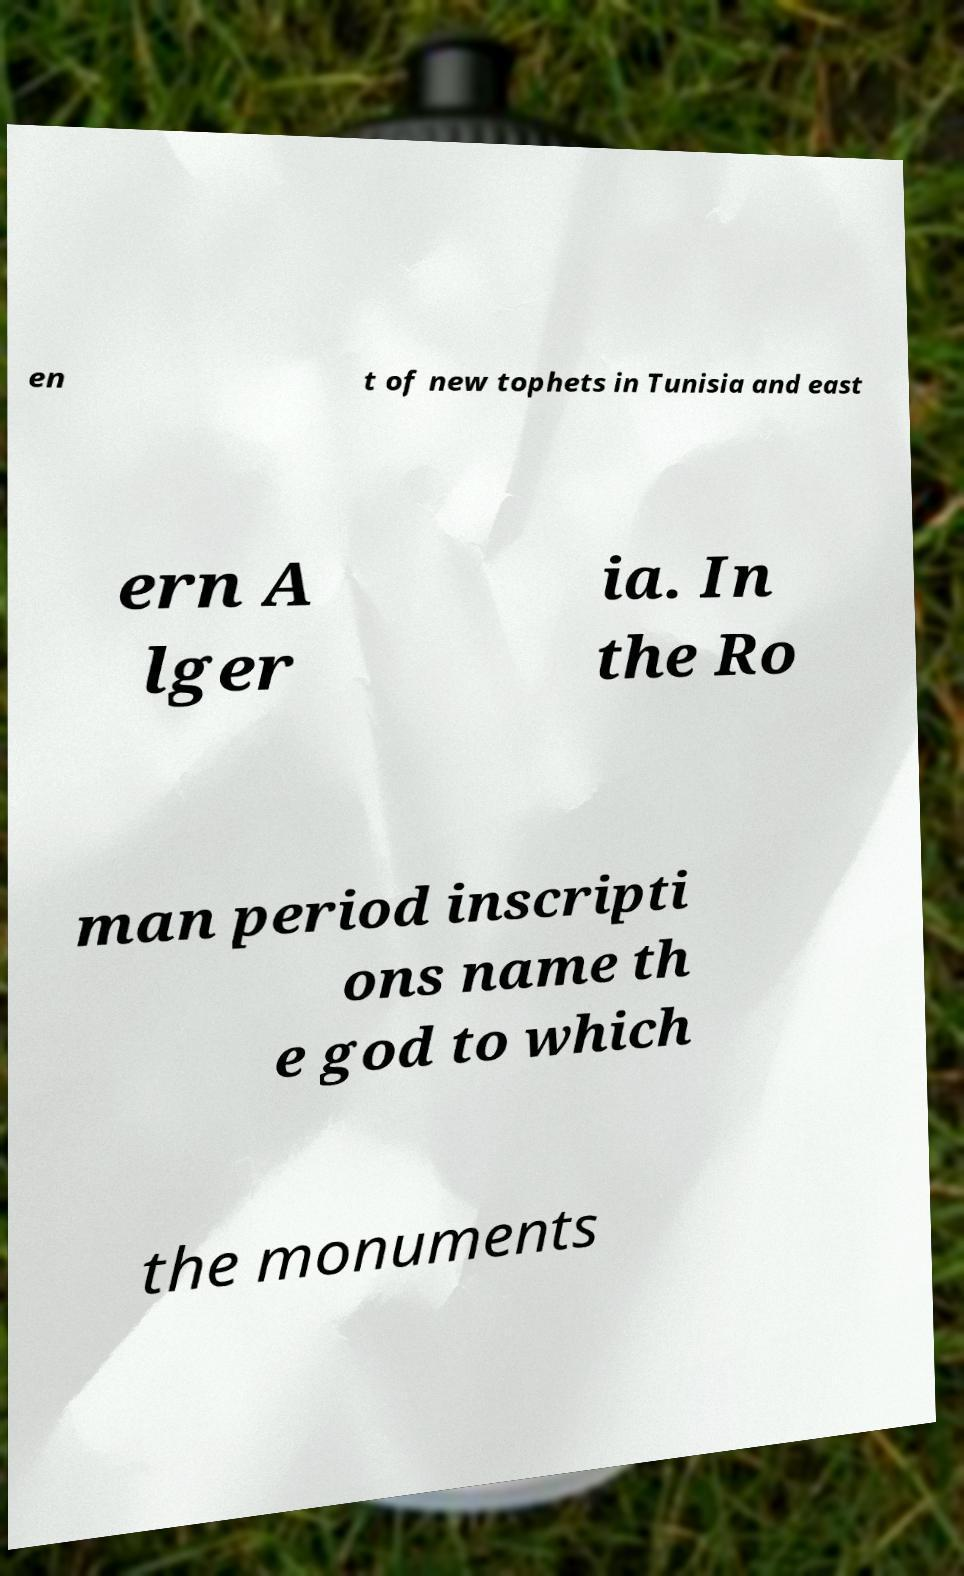There's text embedded in this image that I need extracted. Can you transcribe it verbatim? en t of new tophets in Tunisia and east ern A lger ia. In the Ro man period inscripti ons name th e god to which the monuments 